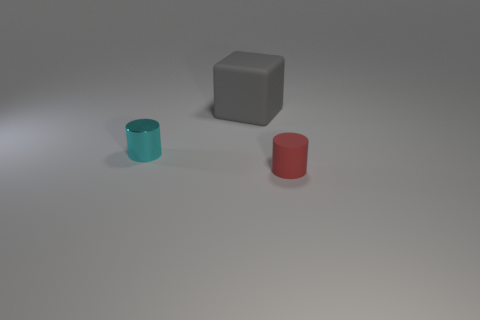Is there any other thing that has the same material as the tiny cyan cylinder?
Give a very brief answer. No. What is the material of the tiny thing behind the thing that is to the right of the matte cube right of the cyan cylinder?
Offer a terse response. Metal. How many tiny objects have the same material as the gray block?
Ensure brevity in your answer.  1. What is the shape of the cyan metal thing that is the same size as the rubber cylinder?
Offer a terse response. Cylinder. There is a shiny cylinder; are there any red objects in front of it?
Keep it short and to the point. Yes. Is there another small rubber object that has the same shape as the tiny cyan object?
Offer a terse response. Yes. Do the small thing that is in front of the cyan metal cylinder and the tiny object that is to the left of the large object have the same shape?
Make the answer very short. Yes. Are there any cyan things of the same size as the cyan cylinder?
Provide a short and direct response. No. Is the number of red matte cylinders that are to the left of the red object the same as the number of large cubes behind the tiny shiny thing?
Give a very brief answer. No. Are the tiny object right of the big gray rubber cube and the thing that is behind the cyan thing made of the same material?
Give a very brief answer. Yes. 